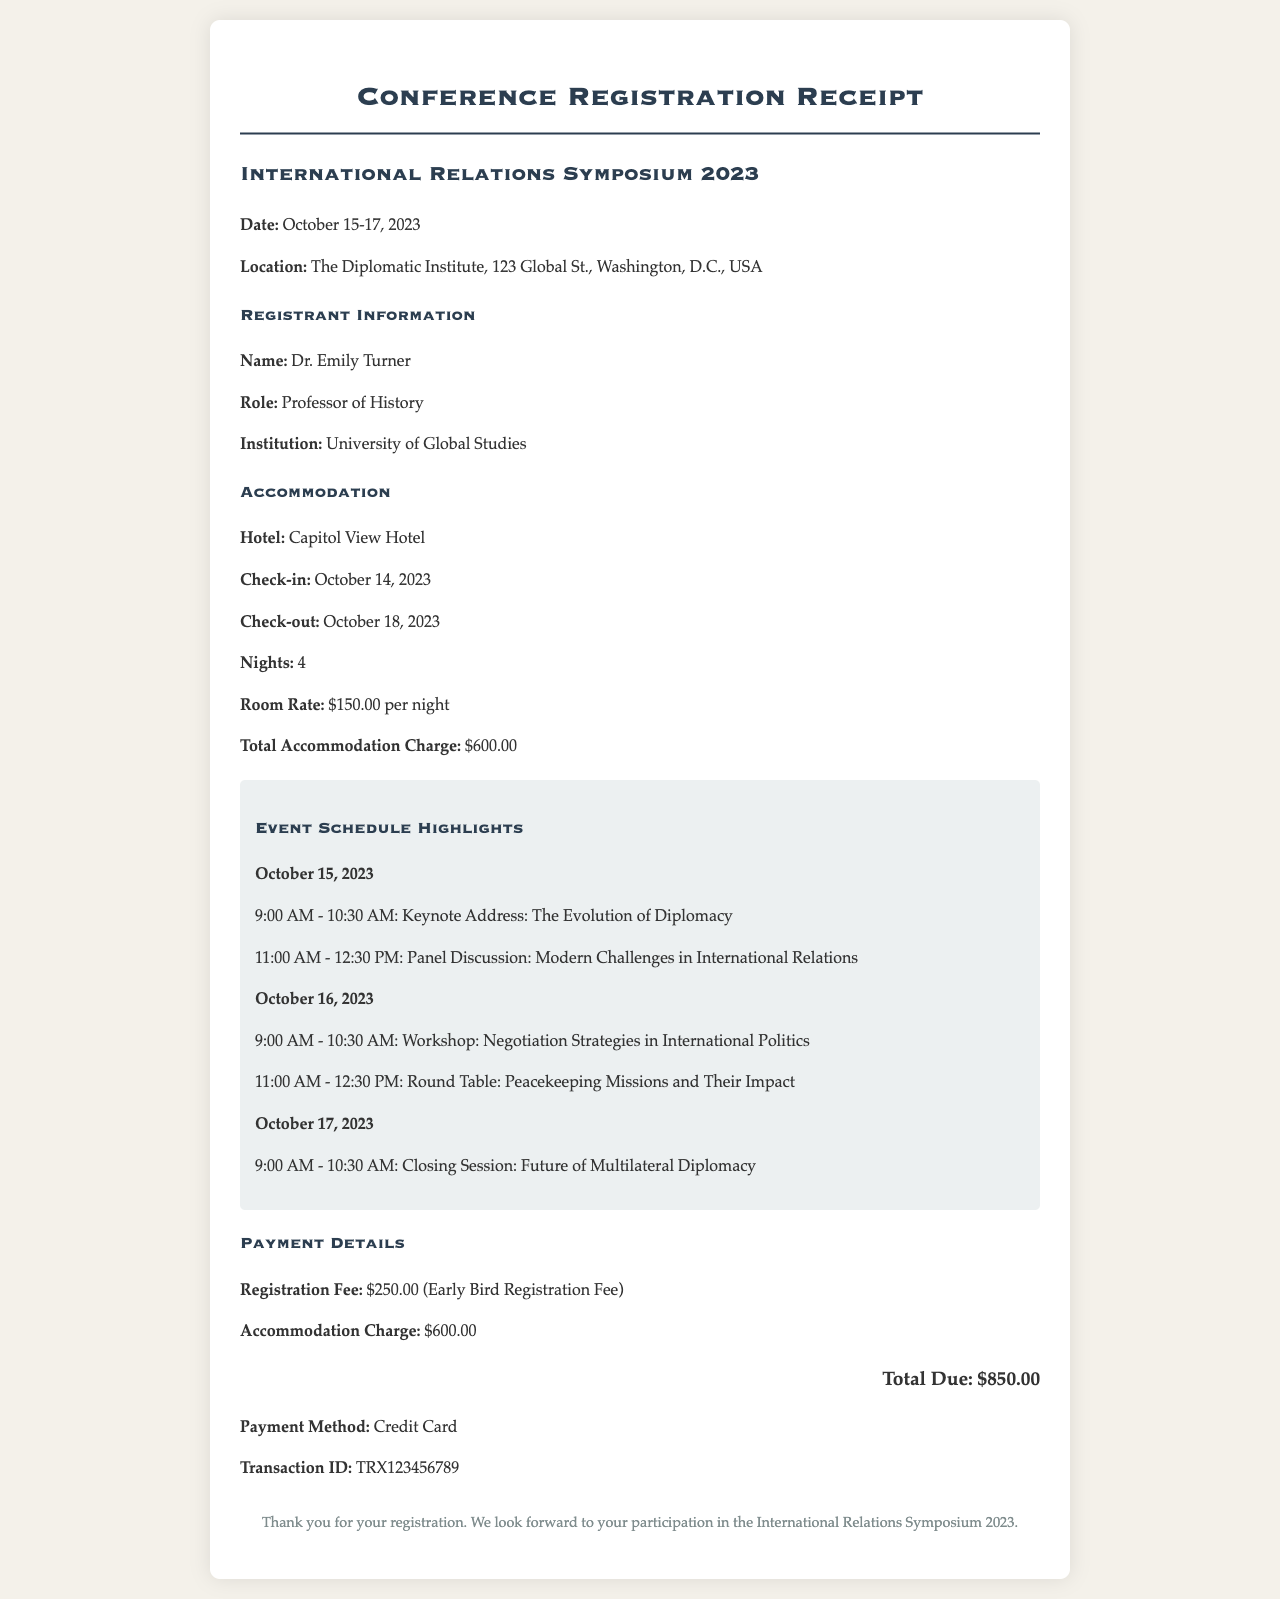What is the name of the symposium? The name of the symposium is clearly stated in the document as "International Relations Symposium 2023."
Answer: International Relations Symposium 2023 What is the location of the event? The document specifies that the location is "The Diplomatic Institute, 123 Global St., Washington, D.C., USA."
Answer: The Diplomatic Institute, 123 Global St., Washington, D.C., USA What are the dates of the symposium? The dates of the symposium are listed as "October 15-17, 2023."
Answer: October 15-17, 2023 How many nights will the accommodation be booked? The document indicates that the check-in and check-out dates reflect a total of 4 nights of accommodation.
Answer: 4 nights What is the total due amount? The total due is provided in the payment details section, combining the registration fee and accommodation charge to sum to $850.00.
Answer: $850.00 Which hotel is the accommodation at? The accommodation details specify that the hotel is "Capitol View Hotel."
Answer: Capitol View Hotel What is the registration fee amount? The document notes the registration fee is "$250.00 (Early Bird Registration Fee)."
Answer: $250.00 What session is scheduled for October 16, 2023? The document lists two sessions on that date: "Workshop: Negotiation Strategies in International Politics" and "Round Table: Peacekeeping Missions and Their Impact."
Answer: Workshop: Negotiation Strategies in International Politics, Round Table: Peacekeeping Missions and Their Impact How did the payment for the registration occur? The payment method is explicitly indicated as "Credit Card" in the payment details section.
Answer: Credit Card 